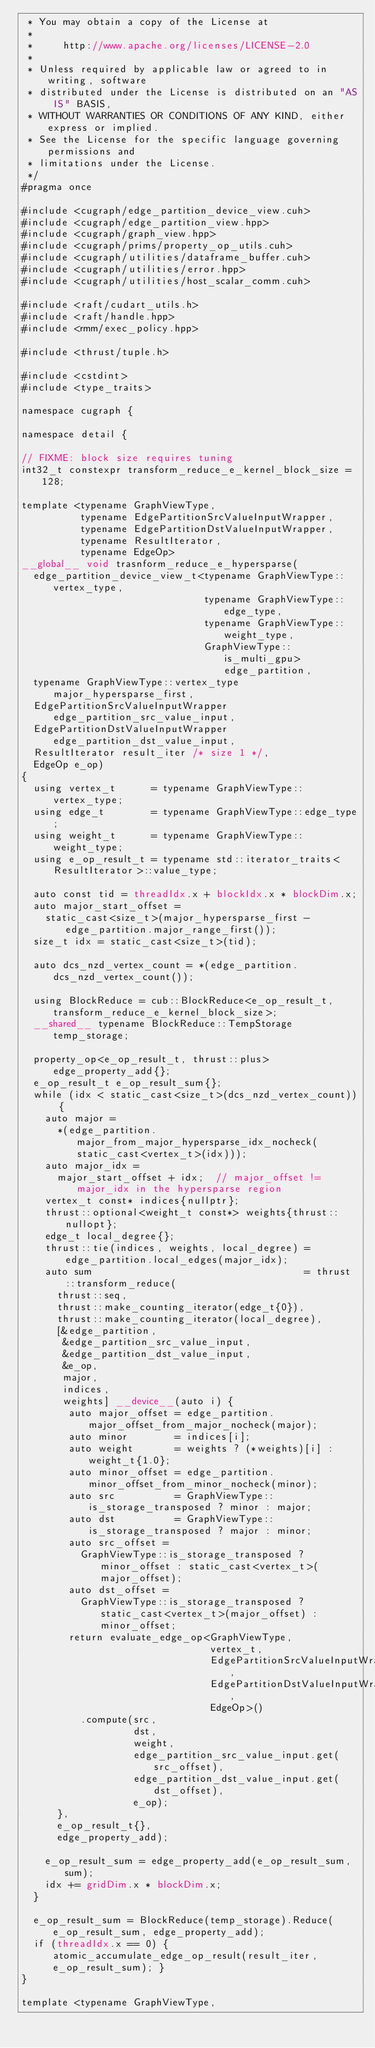Convert code to text. <code><loc_0><loc_0><loc_500><loc_500><_Cuda_> * You may obtain a copy of the License at
 *
 *     http://www.apache.org/licenses/LICENSE-2.0
 *
 * Unless required by applicable law or agreed to in writing, software
 * distributed under the License is distributed on an "AS IS" BASIS,
 * WITHOUT WARRANTIES OR CONDITIONS OF ANY KIND, either express or implied.
 * See the License for the specific language governing permissions and
 * limitations under the License.
 */
#pragma once

#include <cugraph/edge_partition_device_view.cuh>
#include <cugraph/edge_partition_view.hpp>
#include <cugraph/graph_view.hpp>
#include <cugraph/prims/property_op_utils.cuh>
#include <cugraph/utilities/dataframe_buffer.cuh>
#include <cugraph/utilities/error.hpp>
#include <cugraph/utilities/host_scalar_comm.cuh>

#include <raft/cudart_utils.h>
#include <raft/handle.hpp>
#include <rmm/exec_policy.hpp>

#include <thrust/tuple.h>

#include <cstdint>
#include <type_traits>

namespace cugraph {

namespace detail {

// FIXME: block size requires tuning
int32_t constexpr transform_reduce_e_kernel_block_size = 128;

template <typename GraphViewType,
          typename EdgePartitionSrcValueInputWrapper,
          typename EdgePartitionDstValueInputWrapper,
          typename ResultIterator,
          typename EdgeOp>
__global__ void trasnform_reduce_e_hypersparse(
  edge_partition_device_view_t<typename GraphViewType::vertex_type,
                               typename GraphViewType::edge_type,
                               typename GraphViewType::weight_type,
                               GraphViewType::is_multi_gpu> edge_partition,
  typename GraphViewType::vertex_type major_hypersparse_first,
  EdgePartitionSrcValueInputWrapper edge_partition_src_value_input,
  EdgePartitionDstValueInputWrapper edge_partition_dst_value_input,
  ResultIterator result_iter /* size 1 */,
  EdgeOp e_op)
{
  using vertex_t      = typename GraphViewType::vertex_type;
  using edge_t        = typename GraphViewType::edge_type;
  using weight_t      = typename GraphViewType::weight_type;
  using e_op_result_t = typename std::iterator_traits<ResultIterator>::value_type;

  auto const tid = threadIdx.x + blockIdx.x * blockDim.x;
  auto major_start_offset =
    static_cast<size_t>(major_hypersparse_first - edge_partition.major_range_first());
  size_t idx = static_cast<size_t>(tid);

  auto dcs_nzd_vertex_count = *(edge_partition.dcs_nzd_vertex_count());

  using BlockReduce = cub::BlockReduce<e_op_result_t, transform_reduce_e_kernel_block_size>;
  __shared__ typename BlockReduce::TempStorage temp_storage;

  property_op<e_op_result_t, thrust::plus> edge_property_add{};
  e_op_result_t e_op_result_sum{};
  while (idx < static_cast<size_t>(dcs_nzd_vertex_count)) {
    auto major =
      *(edge_partition.major_from_major_hypersparse_idx_nocheck(static_cast<vertex_t>(idx)));
    auto major_idx =
      major_start_offset + idx;  // major_offset != major_idx in the hypersparse region
    vertex_t const* indices{nullptr};
    thrust::optional<weight_t const*> weights{thrust::nullopt};
    edge_t local_degree{};
    thrust::tie(indices, weights, local_degree) = edge_partition.local_edges(major_idx);
    auto sum                                    = thrust::transform_reduce(
      thrust::seq,
      thrust::make_counting_iterator(edge_t{0}),
      thrust::make_counting_iterator(local_degree),
      [&edge_partition,
       &edge_partition_src_value_input,
       &edge_partition_dst_value_input,
       &e_op,
       major,
       indices,
       weights] __device__(auto i) {
        auto major_offset = edge_partition.major_offset_from_major_nocheck(major);
        auto minor        = indices[i];
        auto weight       = weights ? (*weights)[i] : weight_t{1.0};
        auto minor_offset = edge_partition.minor_offset_from_minor_nocheck(minor);
        auto src          = GraphViewType::is_storage_transposed ? minor : major;
        auto dst          = GraphViewType::is_storage_transposed ? major : minor;
        auto src_offset =
          GraphViewType::is_storage_transposed ? minor_offset : static_cast<vertex_t>(major_offset);
        auto dst_offset =
          GraphViewType::is_storage_transposed ? static_cast<vertex_t>(major_offset) : minor_offset;
        return evaluate_edge_op<GraphViewType,
                                vertex_t,
                                EdgePartitionSrcValueInputWrapper,
                                EdgePartitionDstValueInputWrapper,
                                EdgeOp>()
          .compute(src,
                   dst,
                   weight,
                   edge_partition_src_value_input.get(src_offset),
                   edge_partition_dst_value_input.get(dst_offset),
                   e_op);
      },
      e_op_result_t{},
      edge_property_add);

    e_op_result_sum = edge_property_add(e_op_result_sum, sum);
    idx += gridDim.x * blockDim.x;
  }

  e_op_result_sum = BlockReduce(temp_storage).Reduce(e_op_result_sum, edge_property_add);
  if (threadIdx.x == 0) { atomic_accumulate_edge_op_result(result_iter, e_op_result_sum); }
}

template <typename GraphViewType,</code> 